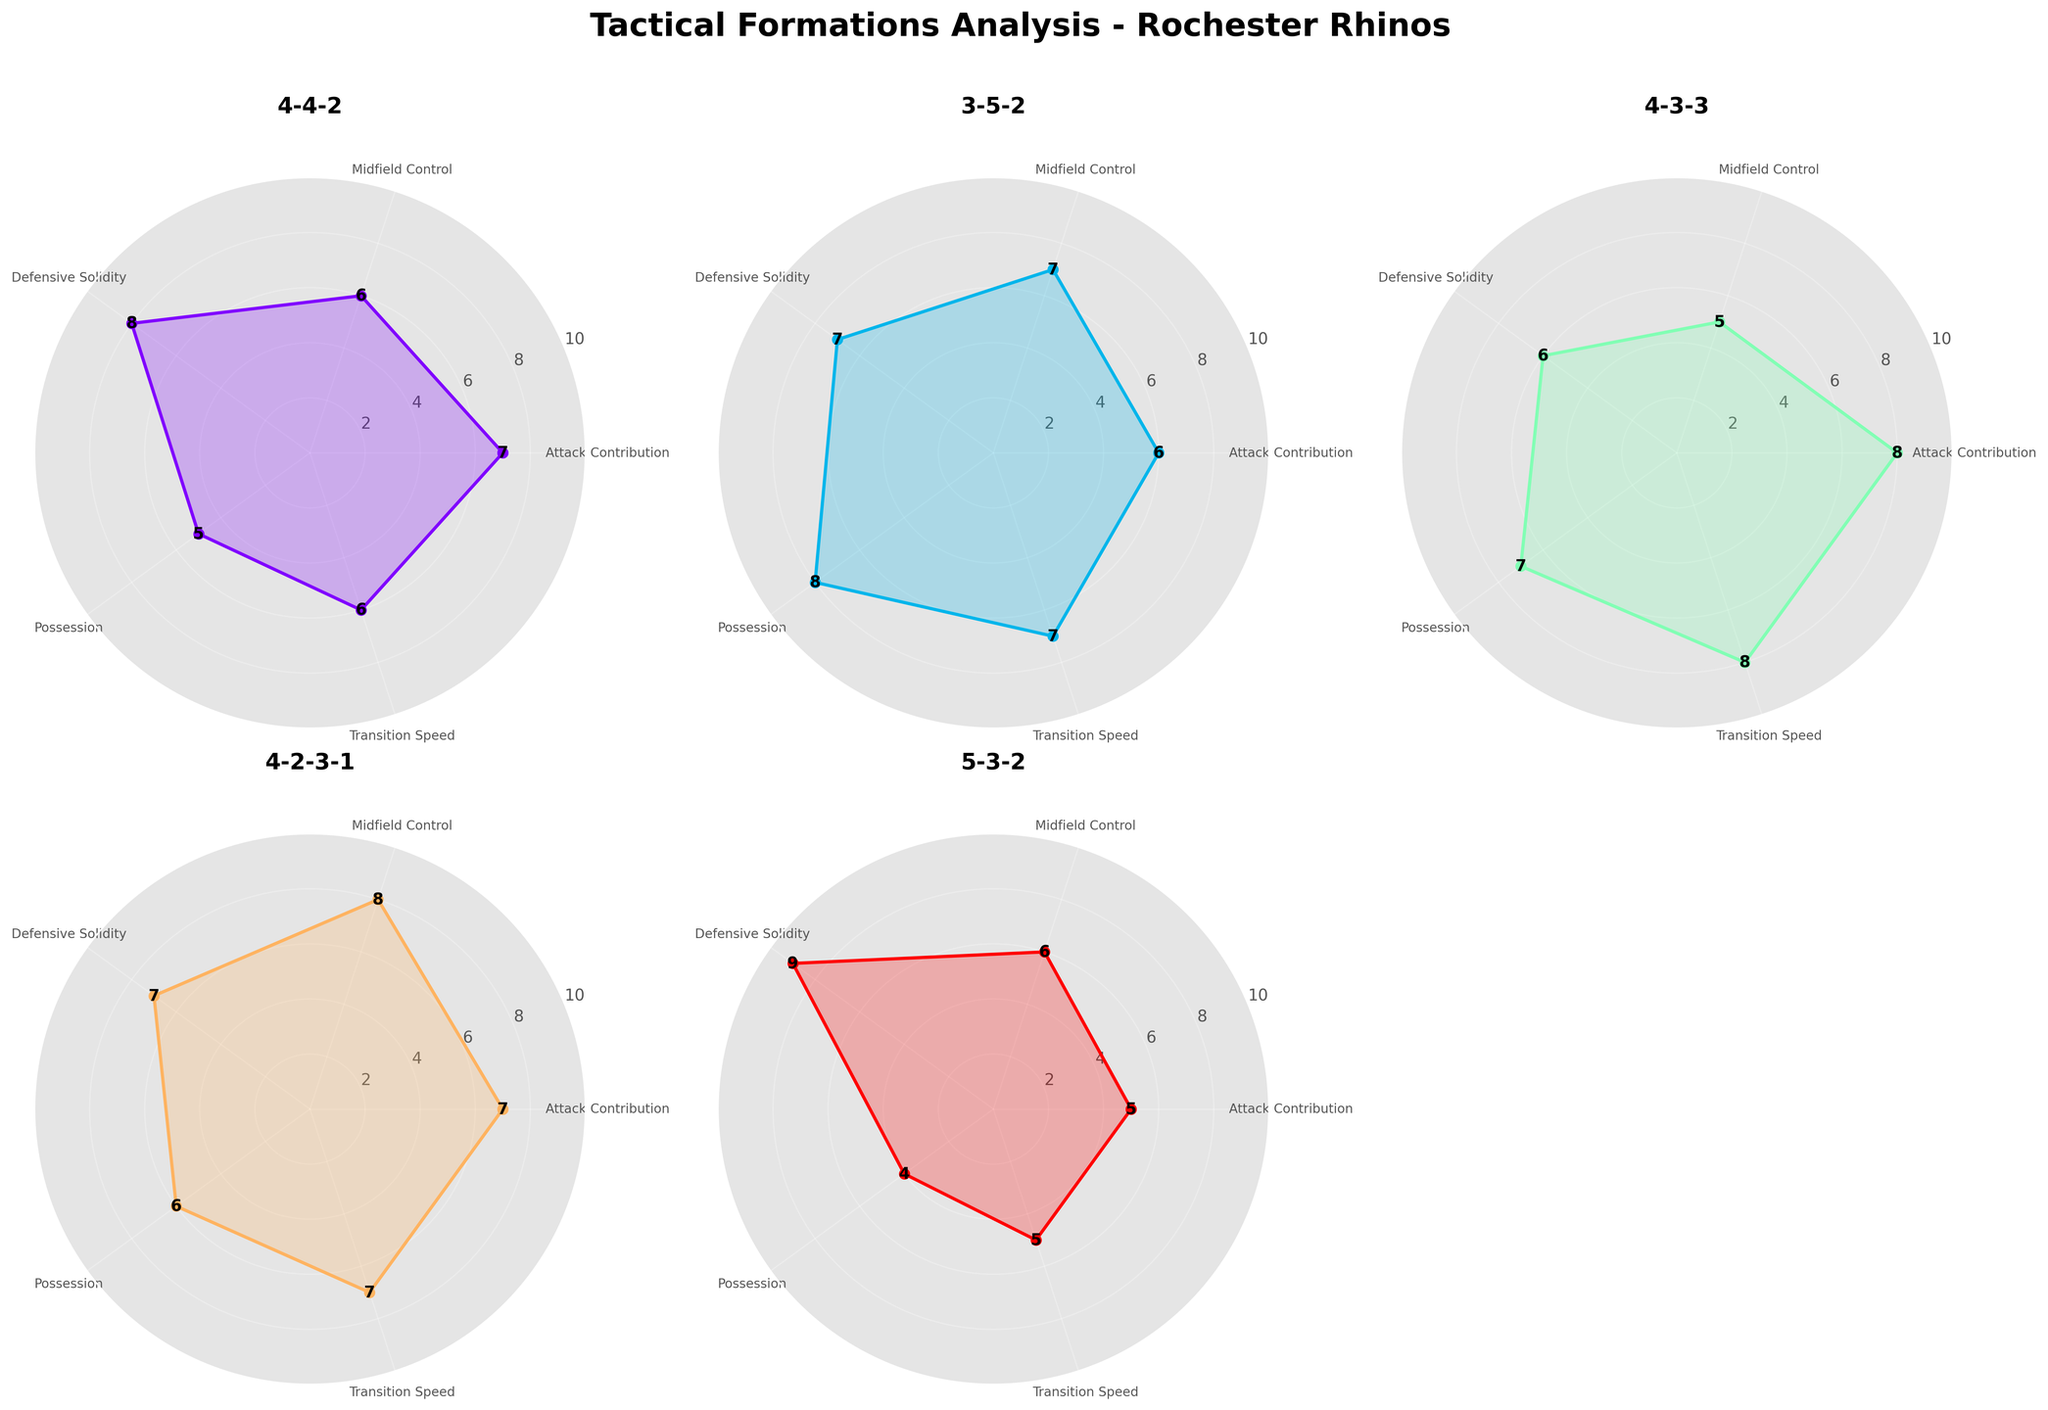What's the overall title of the figure? The title is prominently displayed at the top of the figure. It reads "Tactical Formations Analysis - Rochester Rhinos".
Answer: Tactical Formations Analysis - Rochester Rhinos Which formation appears in the subplot located at the top left corner? The top left corner shows the subplot for the first formation listed in the data, which is "4-4-2".
Answer: 4-4-2 What is the highest value for Defensive Solidity across all formations? The highest value for Defensive Solidity can be seen in the subplot for the "5-3-2" formation, where the value is 9.
Answer: 9 Which formation has the highest Possession value and what is it? The formation "3-5-2" has the highest Possession value, which is 8.
Answer: 3-5-2, 8 Compare the Attack Contribution of 4-3-3 and 5-3-2 formations. Which one is higher and by how much? The Attack Contribution for the 4-3-3 formation is 8, and for the 5-3-2 formation, it is 5. The difference is 3.
Answer: 4-3-3 is higher by 3 What is the average Midfield Control value across all formations? The Midfield Control values are: 6, 7, 5, 8, and 6. Summing them up gives 32, and the average is 32 / 5 = 6.4
Answer: 6.4 For which formation is the Transition Speed highest and what is the value? The highest Transition Speed value is 8, which occurs in the "4-3-3" formation.
Answer: 4-3-3, 8 Between the 4-4-2 and 4-2-3-1 formations, which one has a better Defensive Solidity and by what margin? 4-4-2 has a Defensive Solidity value of 8, while 4-2-3-1 has a value of 7. The margin is 1.
Answer: 4-4-2 by 1 Which formation shows the least value for Possession and what is that value? The formation "5-3-2" has the lowest Possession value, which is 4.
Answer: 5-3-2, 4 